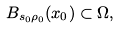<formula> <loc_0><loc_0><loc_500><loc_500>B _ { s _ { 0 } \rho _ { 0 } } ( x _ { 0 } ) \subset \Omega ,</formula> 